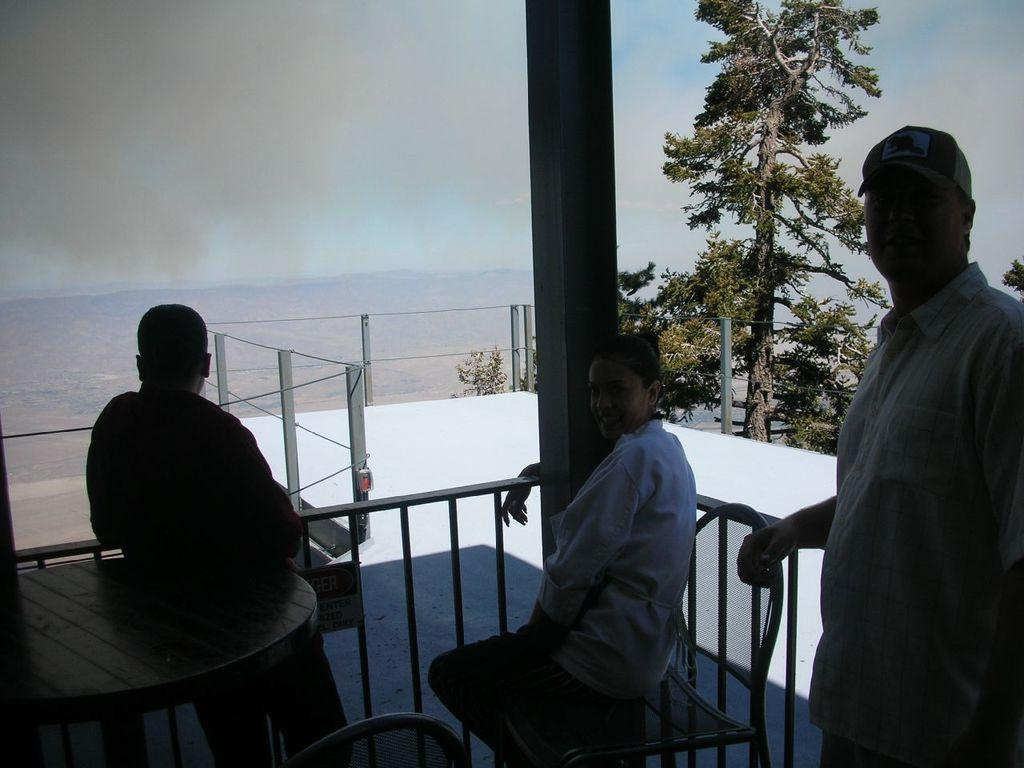How many people are in the image? There are three people in the image. What are the positions of the people in the image? One person is sitting on a chair, and the other two people are standing. What furniture is present in the image? There is a table and another chair in the image. What can be seen in the background of the image? There is a tree visible in the background of the image. How many books are on the table in the image? There are no books visible on the table in the image. 